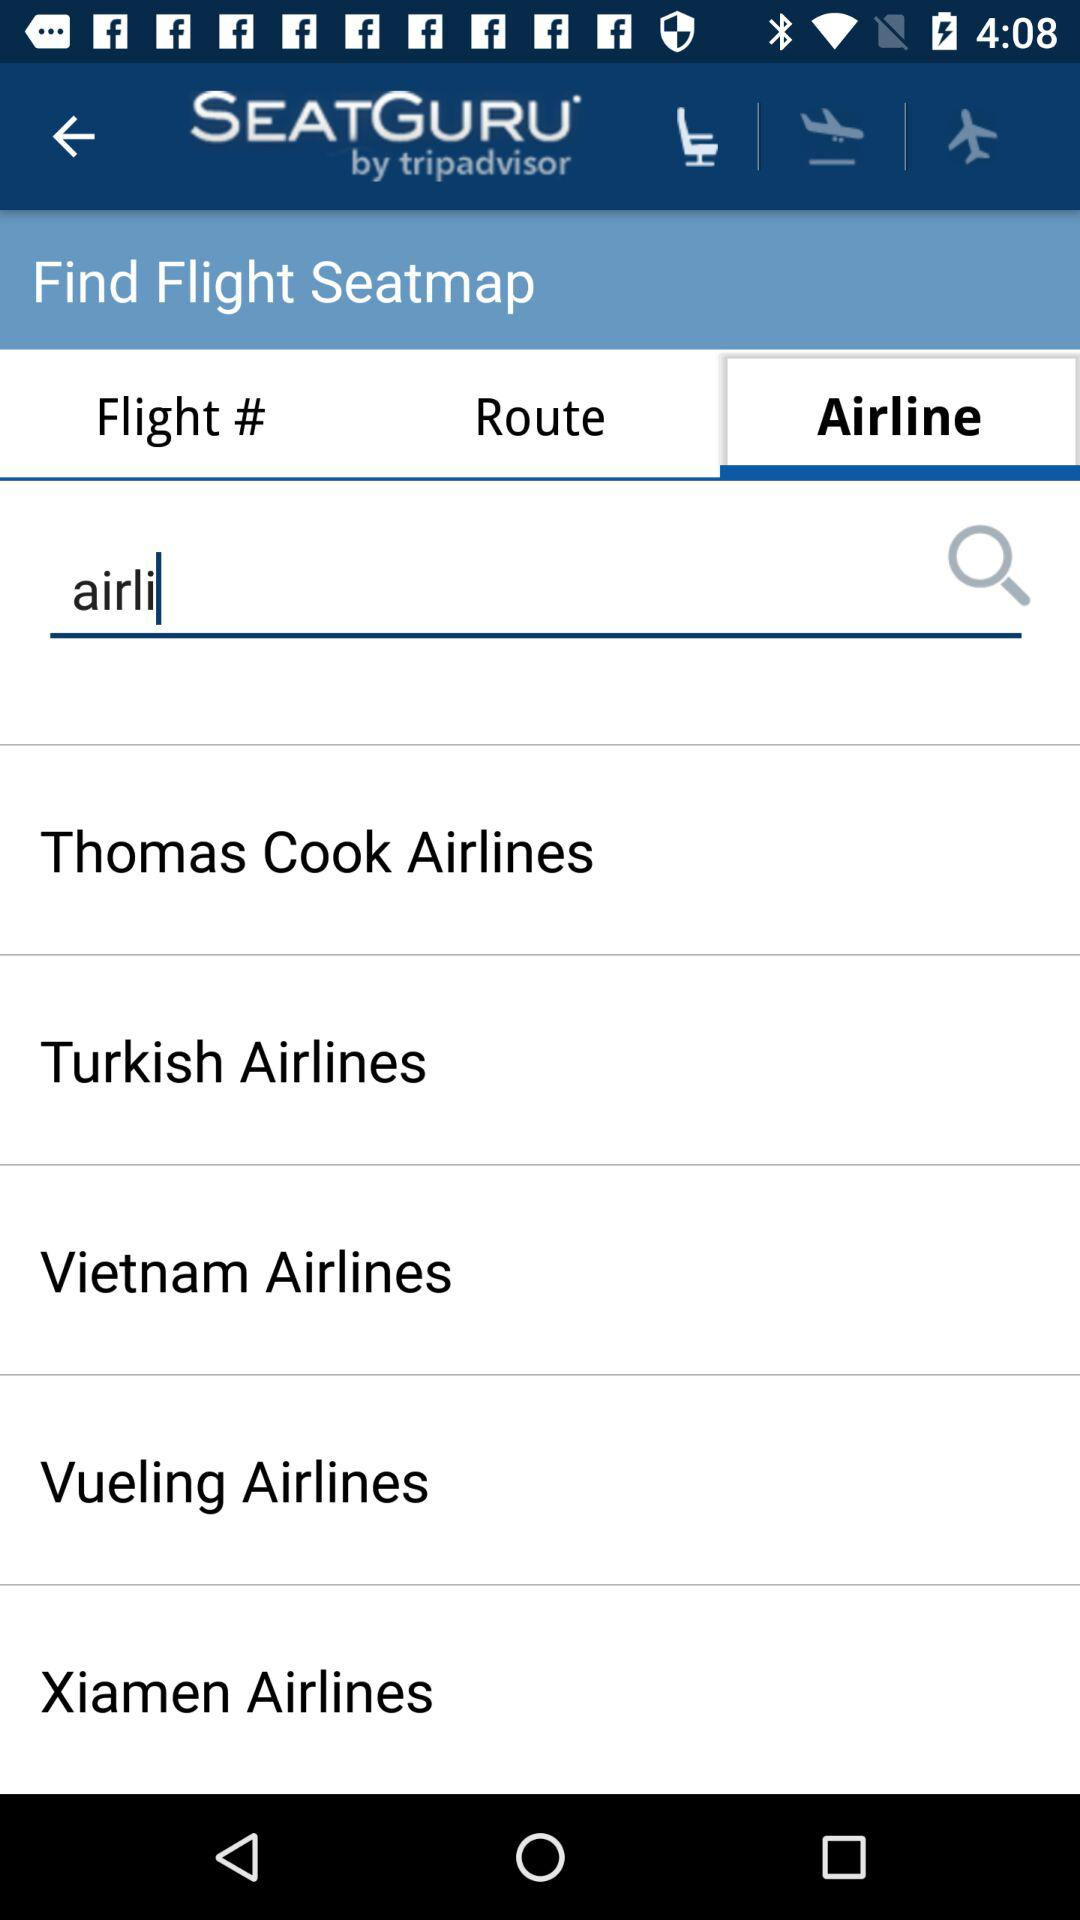How many airline options are there?
Answer the question using a single word or phrase. 5 